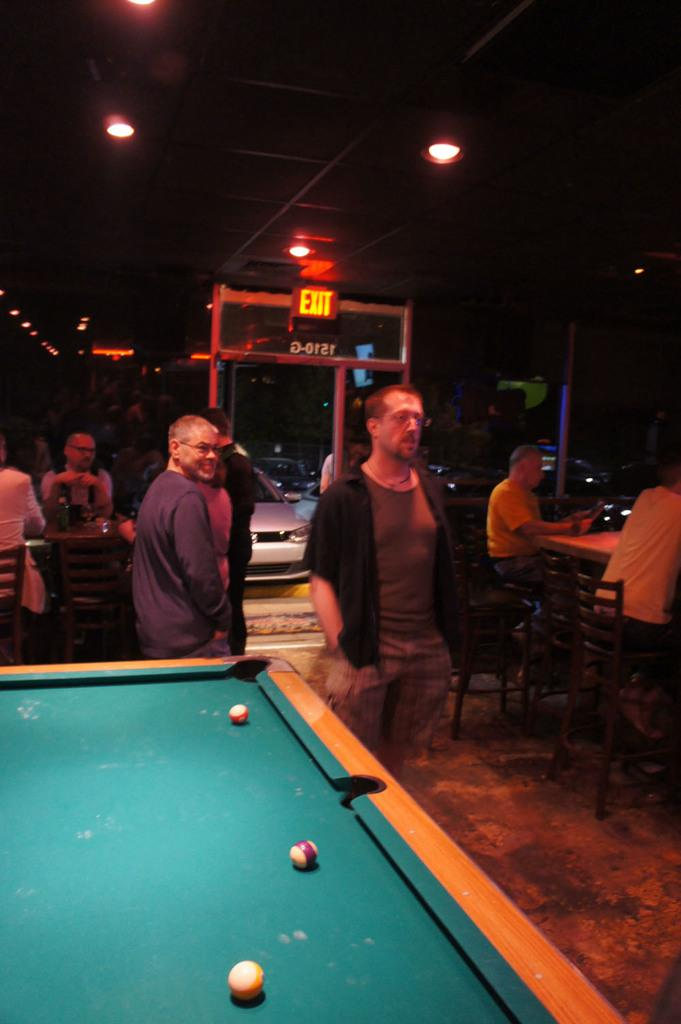What game is being played in the image? There is a snooker board in the image, suggesting that snooker is being played. Who is present in the image? A man is standing in the middle of the image, and there are people sitting on chairs in the image. What can be seen in the background of the image? There is an exit and a vehicle visible in the background. What type of trees can be seen in the image? There are no trees present in the image. What impulse caused the man to suddenly jump in the air in the image? There is no indication in the image that the man jumped in the air or experienced any impulse. 